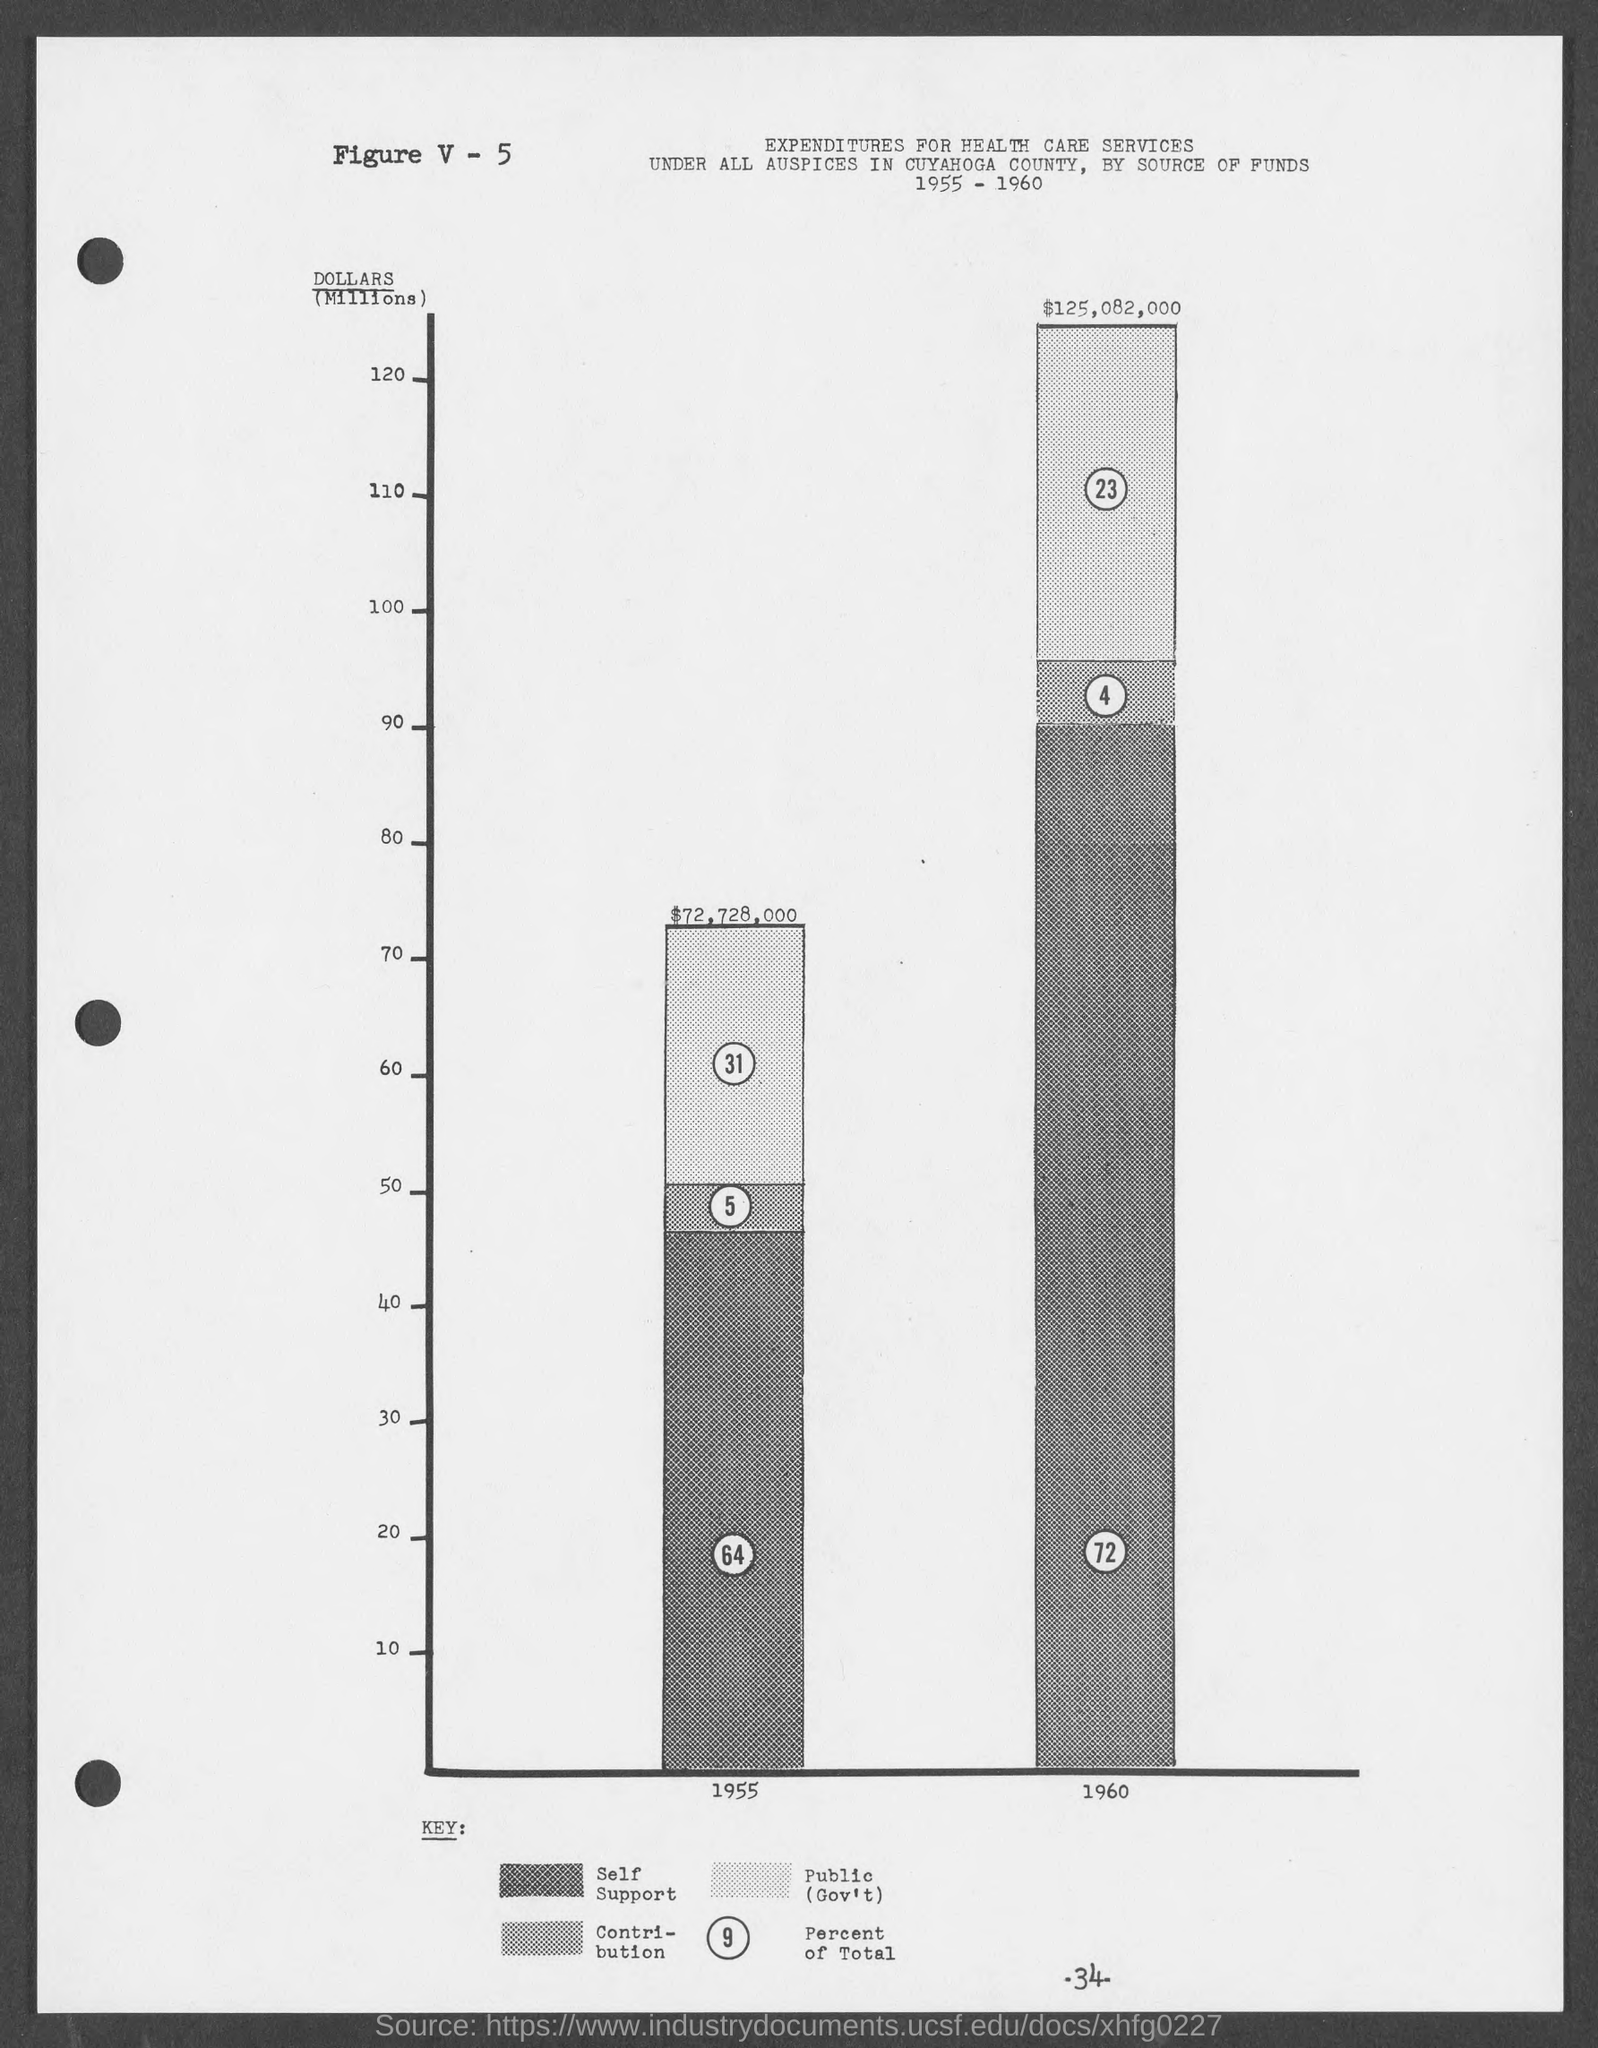Identify some key points in this picture. What is the number?" V minus 5. The number at the bottom of the page is 34. 